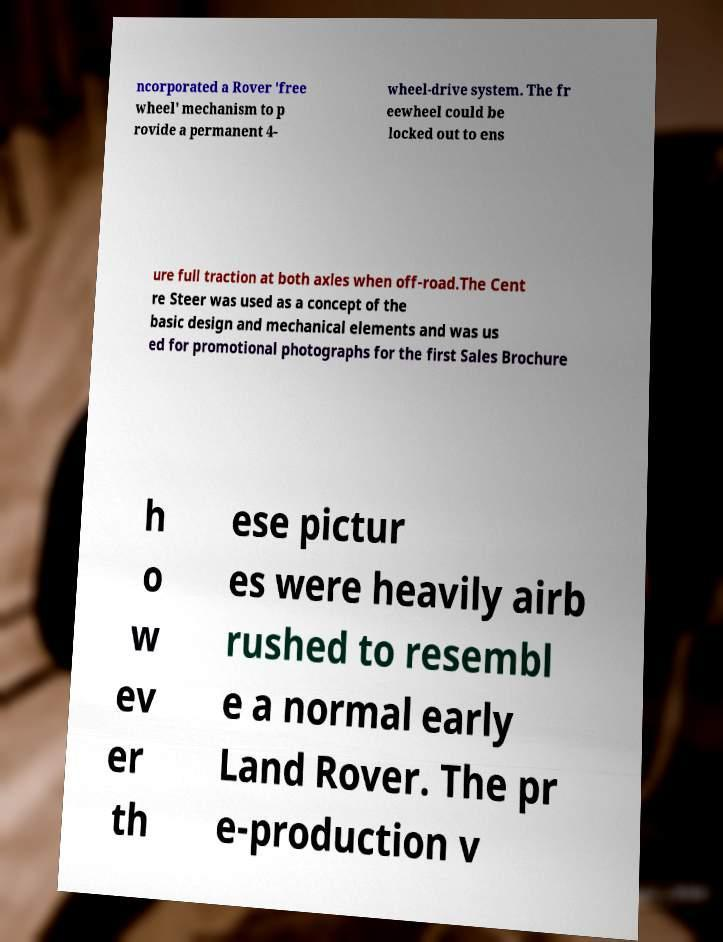Can you read and provide the text displayed in the image?This photo seems to have some interesting text. Can you extract and type it out for me? ncorporated a Rover 'free wheel' mechanism to p rovide a permanent 4- wheel-drive system. The fr eewheel could be locked out to ens ure full traction at both axles when off-road.The Cent re Steer was used as a concept of the basic design and mechanical elements and was us ed for promotional photographs for the first Sales Brochure h o w ev er th ese pictur es were heavily airb rushed to resembl e a normal early Land Rover. The pr e-production v 